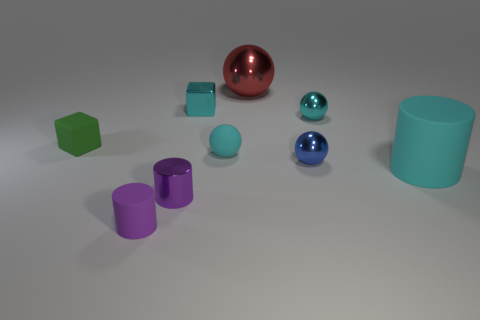Subtract all blue spheres. How many spheres are left? 3 Subtract all blue balls. How many balls are left? 3 Add 1 purple things. How many objects exist? 10 Subtract all brown balls. Subtract all blue blocks. How many balls are left? 4 Subtract all cylinders. How many objects are left? 6 Add 5 purple rubber cubes. How many purple rubber cubes exist? 5 Subtract 0 gray cubes. How many objects are left? 9 Subtract all tiny brown objects. Subtract all tiny spheres. How many objects are left? 6 Add 7 large red spheres. How many large red spheres are left? 8 